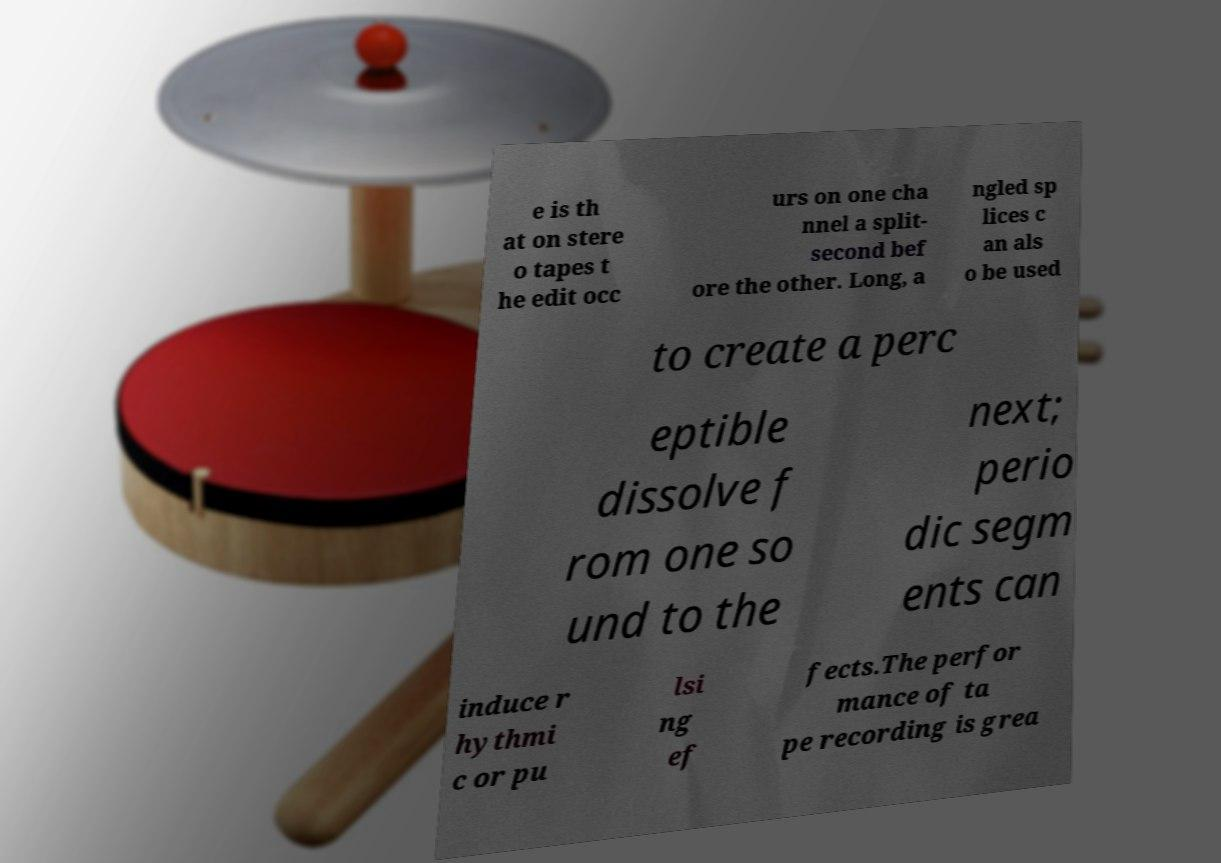I need the written content from this picture converted into text. Can you do that? e is th at on stere o tapes t he edit occ urs on one cha nnel a split- second bef ore the other. Long, a ngled sp lices c an als o be used to create a perc eptible dissolve f rom one so und to the next; perio dic segm ents can induce r hythmi c or pu lsi ng ef fects.The perfor mance of ta pe recording is grea 